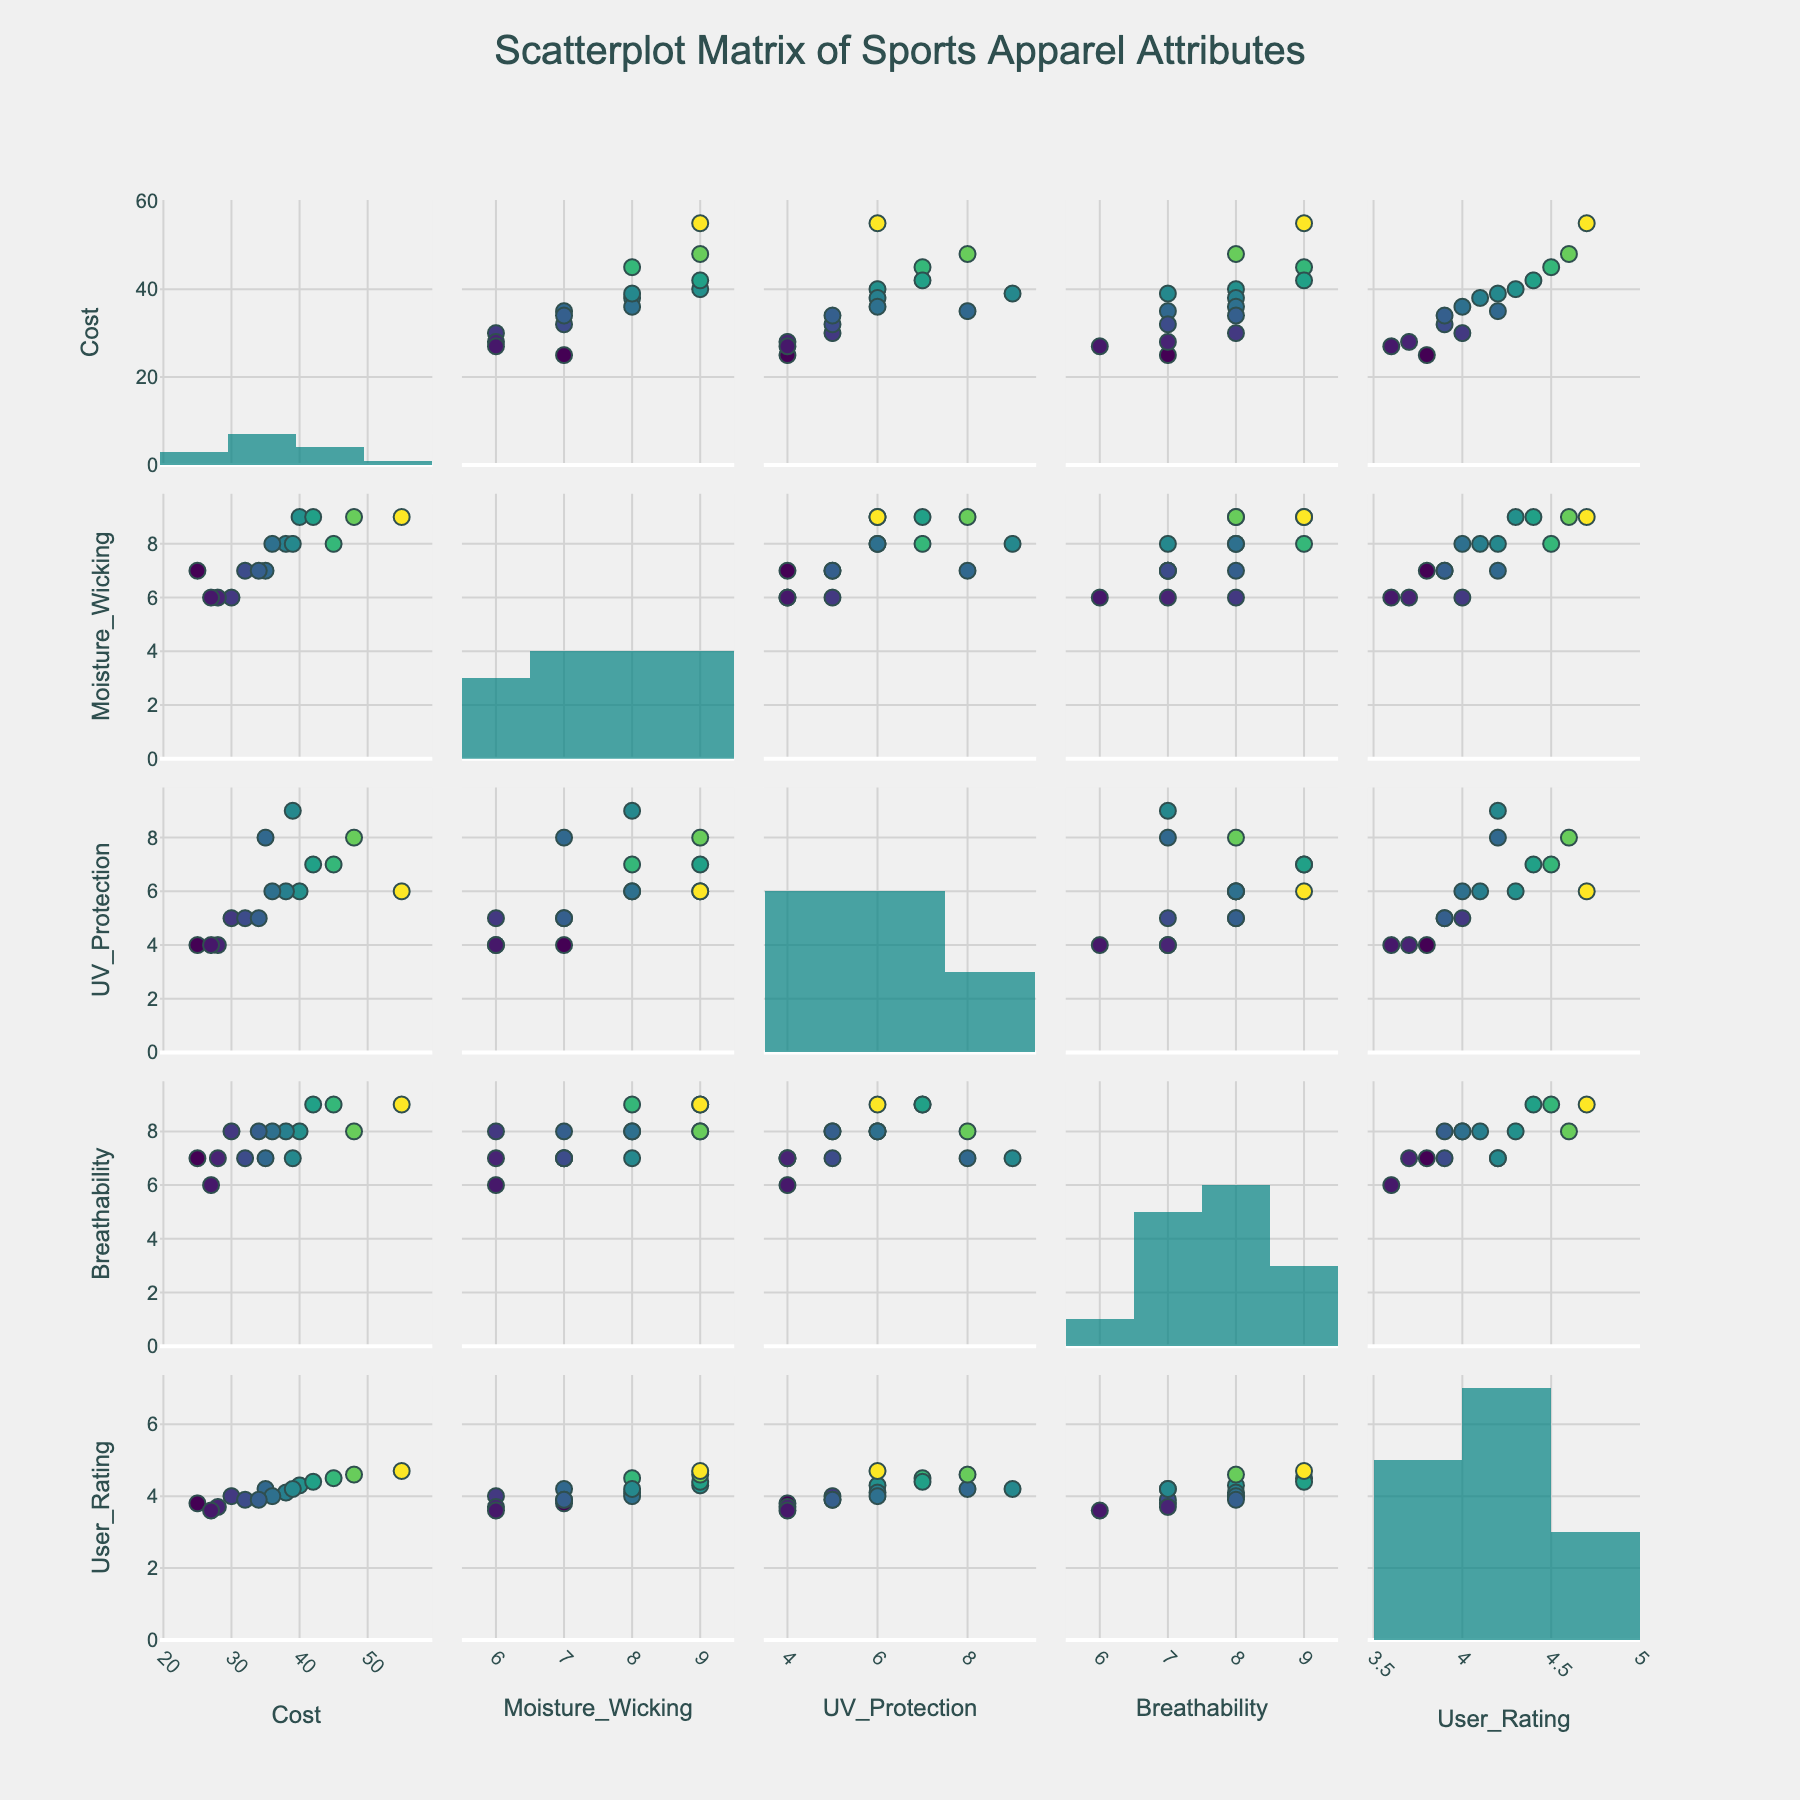How many attributes are being analyzed in the scatterplot matrix? The figure displays a scatterplot matrix with 5 rows and 5 columns, representing different combinations of attributes. Each axis running horizontally and vertically displays one of the five attributes being studied.
Answer: 5 Which attribute has higher values for moisture-wicking, "Nike Dri-FIT" or "Fila Coolmax"? Looking at the scatterplot matrix where the x-axis represents "Moisture_Wicking" and the y-axis represents "Brand", "Nike Dri-FIT" has a moisture-wicking score of 8, while "Fila Coolmax" has a score of 6. Therefore, "Nike Dri-FIT" has higher moisture-wicking values.
Answer: Nike Dri-FIT Is there a positive correlation between cost and user rating? If the scatterplot with "Cost" on the x-axis and "User_Rating" on the y-axis displays an upward trend, then we can conclude there is a positive correlation between cost and user rating. By examining this part of the scatterplot matrix, we can see that higher costs tend to be associated with higher user ratings, suggesting a positive correlation.
Answer: Yes Which brand has the highest user rating and what is that rating? By examining the distribution of user ratings in the scatterplot matrix, we can identify the brand with the highest rating by locating the highest point on the y-axis associated with "User_Rating". This point aligns with "Lululemon Luxtreme" which has the highest user rating of 4.7.
Answer: Lululemon Luxtreme, 4.7 How is UV protection related to breathability for the sports apparel brands? To understand the relationship between UV protection and breathability, we can look at the scatterplot where UV protection is on the x-axis and breathability is on the y-axis. If the points show an upward or downward trend, it implies a correlation. The points appear to show no systematic trend, indicating little or no correlation between UV protection and breathability.
Answer: Little or no correlation Which brand has the lowest cost and how does it score in breathability? Looking at the scatterplot matrix where cost is on the x-axis and brand names are labeled, we can find the brand with the lowest cost. "Champion Double Dry" has the lowest cost of 25. Checking the scatterplot where breathability is on the y-axis, we see it scores 7 in breathability.
Answer: Champion Double Dry, 7 What trend, if any, can be observed between moisture-wicking capabilities and cost? To observe the trend, we look at the scatterplot with moisture-wicking on the x-axis and cost on the y-axis. By observing the spread of the data points, we see that higher moisture-wicking values often correspond to higher costs, indicating a positive correlation.
Answer: Positive correlation Is there a brand that scores high in both UV protection and user rating? By examining the scatterplot matrix section where UV protection is on one axis and user rating is on the other, we look for points that are high on both axes. "The North Face FlashDry" and "Lululemon Luxtreme" both score high in UV protection and have high user ratings.
Answer: Yes, "The North Face FlashDry" and "Lululemon Luxtreme" Which attribute seems most strongly correlated with cost? By examining scatterplots with cost on the y-axis and other attributes (moisture-wicking, UV protection, breathability, user rating) on the x-axis, we see which series of points exhibits the greatest trend. Both moisture-wicking and user rating show noticeable trends, but user rating has a consistent more visible positive correlation with cost.
Answer: User Rating 